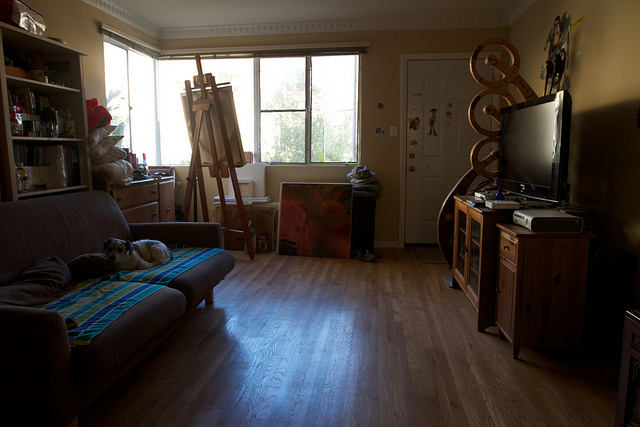What activities might take place in this room? Given the easel and painting supplies, it's likely that painting is a frequent activity. The sofa and television suggest that relaxation and entertainment, like watching TV or reading, also take place here. Additionally, the presence of a guitar in the corner implies that music could be played in this room. 